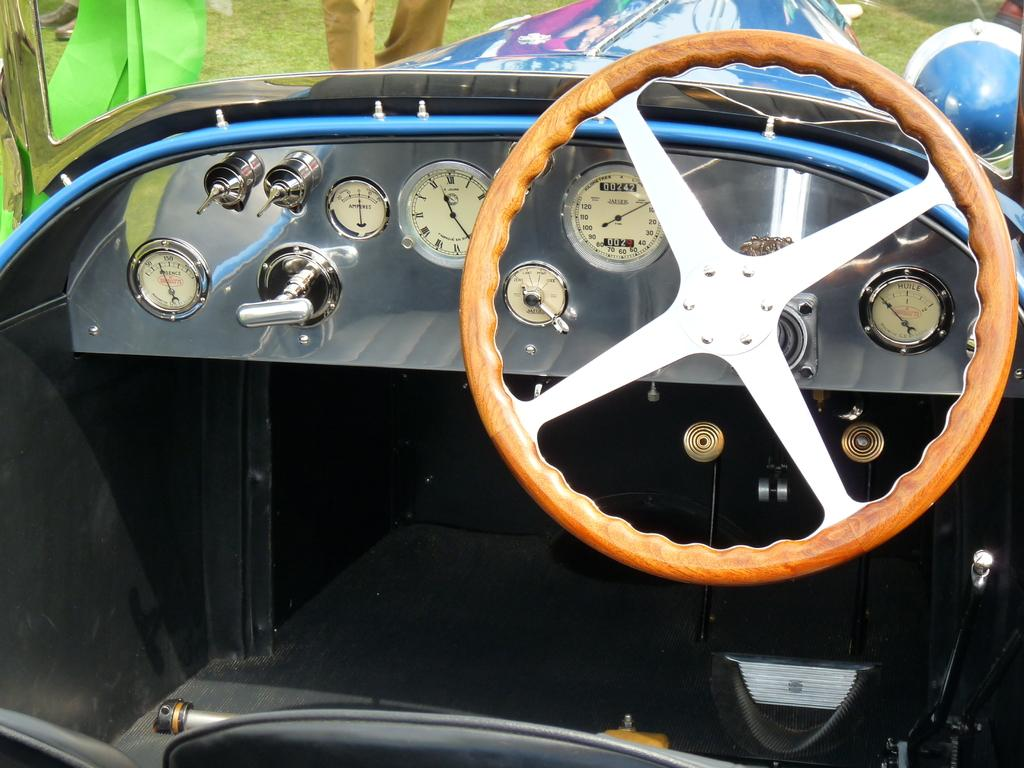What is the main feature of the image? There is a steering wheel in the image. What other instrument related to driving can be seen in the image? There is a speedometer in the image. What additional instruments are present in the image? There are meter gauges in the image. What type of environment is visible in the background of the image? There is grass in the background of the image. What type of mine is visible in the image? There is no mine present in the image; it features a steering wheel, speedometer, meter gauges, and parts of a vehicle. What mathematical operation is being performed in the image? There is no addition or any other mathematical operation being performed in the image; it focuses on driving-related instruments and a grassy background. 